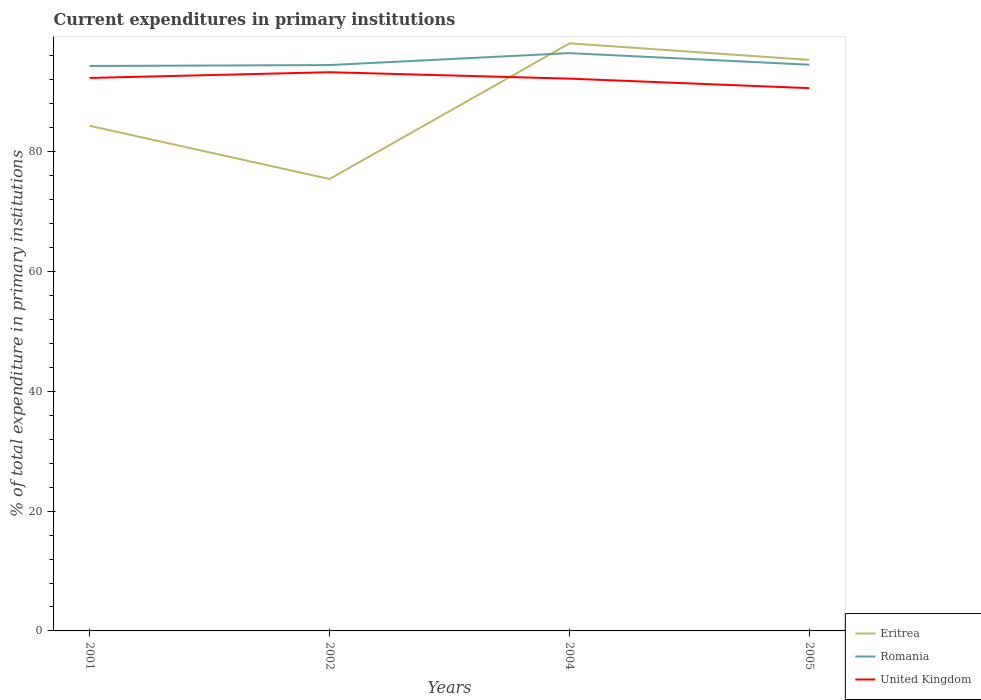Does the line corresponding to Eritrea intersect with the line corresponding to United Kingdom?
Offer a very short reply. Yes. Is the number of lines equal to the number of legend labels?
Your answer should be compact. Yes. Across all years, what is the maximum current expenditures in primary institutions in Romania?
Keep it short and to the point. 94.32. In which year was the current expenditures in primary institutions in United Kingdom maximum?
Give a very brief answer. 2005. What is the total current expenditures in primary institutions in United Kingdom in the graph?
Offer a terse response. 1.07. What is the difference between the highest and the second highest current expenditures in primary institutions in Romania?
Provide a short and direct response. 2.15. How many lines are there?
Offer a terse response. 3. What is the difference between two consecutive major ticks on the Y-axis?
Your response must be concise. 20. Are the values on the major ticks of Y-axis written in scientific E-notation?
Keep it short and to the point. No. Does the graph contain any zero values?
Keep it short and to the point. No. Does the graph contain grids?
Provide a short and direct response. No. What is the title of the graph?
Provide a short and direct response. Current expenditures in primary institutions. Does "Mauritania" appear as one of the legend labels in the graph?
Provide a short and direct response. No. What is the label or title of the Y-axis?
Offer a very short reply. % of total expenditure in primary institutions. What is the % of total expenditure in primary institutions of Eritrea in 2001?
Offer a very short reply. 84.33. What is the % of total expenditure in primary institutions of Romania in 2001?
Provide a short and direct response. 94.32. What is the % of total expenditure in primary institutions of United Kingdom in 2001?
Keep it short and to the point. 92.32. What is the % of total expenditure in primary institutions of Eritrea in 2002?
Keep it short and to the point. 75.45. What is the % of total expenditure in primary institutions in Romania in 2002?
Ensure brevity in your answer.  94.47. What is the % of total expenditure in primary institutions in United Kingdom in 2002?
Your answer should be compact. 93.28. What is the % of total expenditure in primary institutions of Eritrea in 2004?
Make the answer very short. 98.1. What is the % of total expenditure in primary institutions of Romania in 2004?
Provide a short and direct response. 96.47. What is the % of total expenditure in primary institutions in United Kingdom in 2004?
Give a very brief answer. 92.21. What is the % of total expenditure in primary institutions in Eritrea in 2005?
Provide a short and direct response. 95.33. What is the % of total expenditure in primary institutions in Romania in 2005?
Provide a succinct answer. 94.53. What is the % of total expenditure in primary institutions of United Kingdom in 2005?
Ensure brevity in your answer.  90.62. Across all years, what is the maximum % of total expenditure in primary institutions of Eritrea?
Provide a succinct answer. 98.1. Across all years, what is the maximum % of total expenditure in primary institutions of Romania?
Offer a very short reply. 96.47. Across all years, what is the maximum % of total expenditure in primary institutions of United Kingdom?
Make the answer very short. 93.28. Across all years, what is the minimum % of total expenditure in primary institutions in Eritrea?
Ensure brevity in your answer.  75.45. Across all years, what is the minimum % of total expenditure in primary institutions in Romania?
Keep it short and to the point. 94.32. Across all years, what is the minimum % of total expenditure in primary institutions of United Kingdom?
Offer a terse response. 90.62. What is the total % of total expenditure in primary institutions of Eritrea in the graph?
Give a very brief answer. 353.22. What is the total % of total expenditure in primary institutions of Romania in the graph?
Make the answer very short. 379.8. What is the total % of total expenditure in primary institutions of United Kingdom in the graph?
Offer a terse response. 368.43. What is the difference between the % of total expenditure in primary institutions of Eritrea in 2001 and that in 2002?
Offer a terse response. 8.88. What is the difference between the % of total expenditure in primary institutions of Romania in 2001 and that in 2002?
Offer a terse response. -0.15. What is the difference between the % of total expenditure in primary institutions in United Kingdom in 2001 and that in 2002?
Provide a short and direct response. -0.96. What is the difference between the % of total expenditure in primary institutions of Eritrea in 2001 and that in 2004?
Offer a terse response. -13.76. What is the difference between the % of total expenditure in primary institutions of Romania in 2001 and that in 2004?
Offer a very short reply. -2.15. What is the difference between the % of total expenditure in primary institutions in United Kingdom in 2001 and that in 2004?
Ensure brevity in your answer.  0.11. What is the difference between the % of total expenditure in primary institutions in Eritrea in 2001 and that in 2005?
Make the answer very short. -11. What is the difference between the % of total expenditure in primary institutions of Romania in 2001 and that in 2005?
Ensure brevity in your answer.  -0.21. What is the difference between the % of total expenditure in primary institutions of United Kingdom in 2001 and that in 2005?
Keep it short and to the point. 1.7. What is the difference between the % of total expenditure in primary institutions in Eritrea in 2002 and that in 2004?
Ensure brevity in your answer.  -22.65. What is the difference between the % of total expenditure in primary institutions in Romania in 2002 and that in 2004?
Provide a short and direct response. -2. What is the difference between the % of total expenditure in primary institutions of United Kingdom in 2002 and that in 2004?
Your response must be concise. 1.07. What is the difference between the % of total expenditure in primary institutions in Eritrea in 2002 and that in 2005?
Your answer should be compact. -19.88. What is the difference between the % of total expenditure in primary institutions of Romania in 2002 and that in 2005?
Give a very brief answer. -0.06. What is the difference between the % of total expenditure in primary institutions of United Kingdom in 2002 and that in 2005?
Give a very brief answer. 2.66. What is the difference between the % of total expenditure in primary institutions of Eritrea in 2004 and that in 2005?
Ensure brevity in your answer.  2.77. What is the difference between the % of total expenditure in primary institutions in Romania in 2004 and that in 2005?
Give a very brief answer. 1.94. What is the difference between the % of total expenditure in primary institutions of United Kingdom in 2004 and that in 2005?
Provide a short and direct response. 1.59. What is the difference between the % of total expenditure in primary institutions in Eritrea in 2001 and the % of total expenditure in primary institutions in Romania in 2002?
Your answer should be very brief. -10.14. What is the difference between the % of total expenditure in primary institutions of Eritrea in 2001 and the % of total expenditure in primary institutions of United Kingdom in 2002?
Keep it short and to the point. -8.95. What is the difference between the % of total expenditure in primary institutions of Romania in 2001 and the % of total expenditure in primary institutions of United Kingdom in 2002?
Offer a very short reply. 1.04. What is the difference between the % of total expenditure in primary institutions of Eritrea in 2001 and the % of total expenditure in primary institutions of Romania in 2004?
Offer a terse response. -12.13. What is the difference between the % of total expenditure in primary institutions of Eritrea in 2001 and the % of total expenditure in primary institutions of United Kingdom in 2004?
Keep it short and to the point. -7.87. What is the difference between the % of total expenditure in primary institutions of Romania in 2001 and the % of total expenditure in primary institutions of United Kingdom in 2004?
Your response must be concise. 2.11. What is the difference between the % of total expenditure in primary institutions of Eritrea in 2001 and the % of total expenditure in primary institutions of Romania in 2005?
Provide a succinct answer. -10.2. What is the difference between the % of total expenditure in primary institutions in Eritrea in 2001 and the % of total expenditure in primary institutions in United Kingdom in 2005?
Make the answer very short. -6.28. What is the difference between the % of total expenditure in primary institutions in Romania in 2001 and the % of total expenditure in primary institutions in United Kingdom in 2005?
Provide a succinct answer. 3.7. What is the difference between the % of total expenditure in primary institutions of Eritrea in 2002 and the % of total expenditure in primary institutions of Romania in 2004?
Your answer should be compact. -21.02. What is the difference between the % of total expenditure in primary institutions of Eritrea in 2002 and the % of total expenditure in primary institutions of United Kingdom in 2004?
Your answer should be compact. -16.76. What is the difference between the % of total expenditure in primary institutions of Romania in 2002 and the % of total expenditure in primary institutions of United Kingdom in 2004?
Give a very brief answer. 2.26. What is the difference between the % of total expenditure in primary institutions in Eritrea in 2002 and the % of total expenditure in primary institutions in Romania in 2005?
Your answer should be compact. -19.08. What is the difference between the % of total expenditure in primary institutions in Eritrea in 2002 and the % of total expenditure in primary institutions in United Kingdom in 2005?
Give a very brief answer. -15.17. What is the difference between the % of total expenditure in primary institutions of Romania in 2002 and the % of total expenditure in primary institutions of United Kingdom in 2005?
Ensure brevity in your answer.  3.85. What is the difference between the % of total expenditure in primary institutions of Eritrea in 2004 and the % of total expenditure in primary institutions of Romania in 2005?
Your answer should be compact. 3.57. What is the difference between the % of total expenditure in primary institutions of Eritrea in 2004 and the % of total expenditure in primary institutions of United Kingdom in 2005?
Ensure brevity in your answer.  7.48. What is the difference between the % of total expenditure in primary institutions of Romania in 2004 and the % of total expenditure in primary institutions of United Kingdom in 2005?
Offer a terse response. 5.85. What is the average % of total expenditure in primary institutions of Eritrea per year?
Offer a terse response. 88.3. What is the average % of total expenditure in primary institutions in Romania per year?
Provide a succinct answer. 94.95. What is the average % of total expenditure in primary institutions in United Kingdom per year?
Offer a terse response. 92.11. In the year 2001, what is the difference between the % of total expenditure in primary institutions in Eritrea and % of total expenditure in primary institutions in Romania?
Give a very brief answer. -9.99. In the year 2001, what is the difference between the % of total expenditure in primary institutions in Eritrea and % of total expenditure in primary institutions in United Kingdom?
Keep it short and to the point. -7.99. In the year 2001, what is the difference between the % of total expenditure in primary institutions in Romania and % of total expenditure in primary institutions in United Kingdom?
Provide a short and direct response. 2. In the year 2002, what is the difference between the % of total expenditure in primary institutions of Eritrea and % of total expenditure in primary institutions of Romania?
Provide a short and direct response. -19.02. In the year 2002, what is the difference between the % of total expenditure in primary institutions in Eritrea and % of total expenditure in primary institutions in United Kingdom?
Provide a short and direct response. -17.83. In the year 2002, what is the difference between the % of total expenditure in primary institutions of Romania and % of total expenditure in primary institutions of United Kingdom?
Ensure brevity in your answer.  1.19. In the year 2004, what is the difference between the % of total expenditure in primary institutions of Eritrea and % of total expenditure in primary institutions of Romania?
Ensure brevity in your answer.  1.63. In the year 2004, what is the difference between the % of total expenditure in primary institutions in Eritrea and % of total expenditure in primary institutions in United Kingdom?
Provide a succinct answer. 5.89. In the year 2004, what is the difference between the % of total expenditure in primary institutions of Romania and % of total expenditure in primary institutions of United Kingdom?
Provide a short and direct response. 4.26. In the year 2005, what is the difference between the % of total expenditure in primary institutions in Eritrea and % of total expenditure in primary institutions in Romania?
Ensure brevity in your answer.  0.8. In the year 2005, what is the difference between the % of total expenditure in primary institutions of Eritrea and % of total expenditure in primary institutions of United Kingdom?
Your answer should be compact. 4.71. In the year 2005, what is the difference between the % of total expenditure in primary institutions of Romania and % of total expenditure in primary institutions of United Kingdom?
Make the answer very short. 3.91. What is the ratio of the % of total expenditure in primary institutions in Eritrea in 2001 to that in 2002?
Offer a very short reply. 1.12. What is the ratio of the % of total expenditure in primary institutions of United Kingdom in 2001 to that in 2002?
Ensure brevity in your answer.  0.99. What is the ratio of the % of total expenditure in primary institutions of Eritrea in 2001 to that in 2004?
Make the answer very short. 0.86. What is the ratio of the % of total expenditure in primary institutions of Romania in 2001 to that in 2004?
Ensure brevity in your answer.  0.98. What is the ratio of the % of total expenditure in primary institutions of Eritrea in 2001 to that in 2005?
Your answer should be very brief. 0.88. What is the ratio of the % of total expenditure in primary institutions in United Kingdom in 2001 to that in 2005?
Make the answer very short. 1.02. What is the ratio of the % of total expenditure in primary institutions in Eritrea in 2002 to that in 2004?
Provide a short and direct response. 0.77. What is the ratio of the % of total expenditure in primary institutions of Romania in 2002 to that in 2004?
Keep it short and to the point. 0.98. What is the ratio of the % of total expenditure in primary institutions in United Kingdom in 2002 to that in 2004?
Your response must be concise. 1.01. What is the ratio of the % of total expenditure in primary institutions in Eritrea in 2002 to that in 2005?
Offer a very short reply. 0.79. What is the ratio of the % of total expenditure in primary institutions of Romania in 2002 to that in 2005?
Your answer should be compact. 1. What is the ratio of the % of total expenditure in primary institutions of United Kingdom in 2002 to that in 2005?
Keep it short and to the point. 1.03. What is the ratio of the % of total expenditure in primary institutions in Eritrea in 2004 to that in 2005?
Provide a succinct answer. 1.03. What is the ratio of the % of total expenditure in primary institutions in Romania in 2004 to that in 2005?
Give a very brief answer. 1.02. What is the ratio of the % of total expenditure in primary institutions in United Kingdom in 2004 to that in 2005?
Your answer should be very brief. 1.02. What is the difference between the highest and the second highest % of total expenditure in primary institutions in Eritrea?
Your answer should be very brief. 2.77. What is the difference between the highest and the second highest % of total expenditure in primary institutions of Romania?
Keep it short and to the point. 1.94. What is the difference between the highest and the second highest % of total expenditure in primary institutions of United Kingdom?
Give a very brief answer. 0.96. What is the difference between the highest and the lowest % of total expenditure in primary institutions in Eritrea?
Your response must be concise. 22.65. What is the difference between the highest and the lowest % of total expenditure in primary institutions of Romania?
Your answer should be compact. 2.15. What is the difference between the highest and the lowest % of total expenditure in primary institutions of United Kingdom?
Provide a succinct answer. 2.66. 